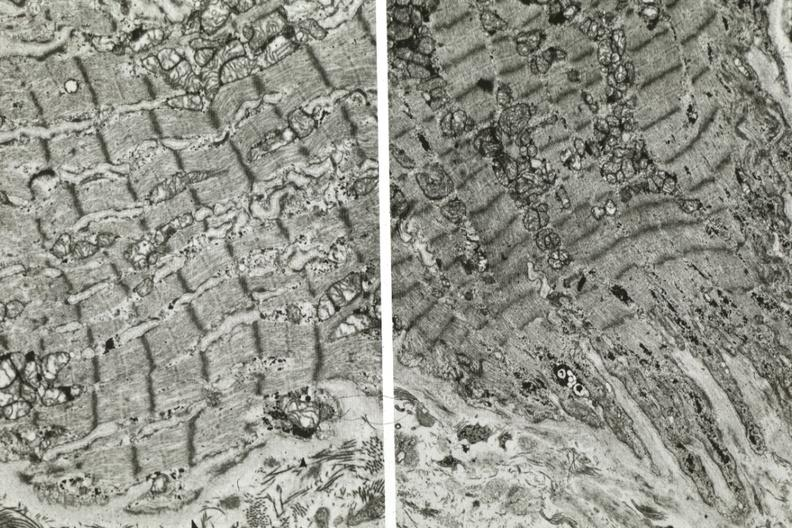what shows dilated sarcoplasmic reticulum?
Answer the question using a single word or phrase. Another fiber other frame 